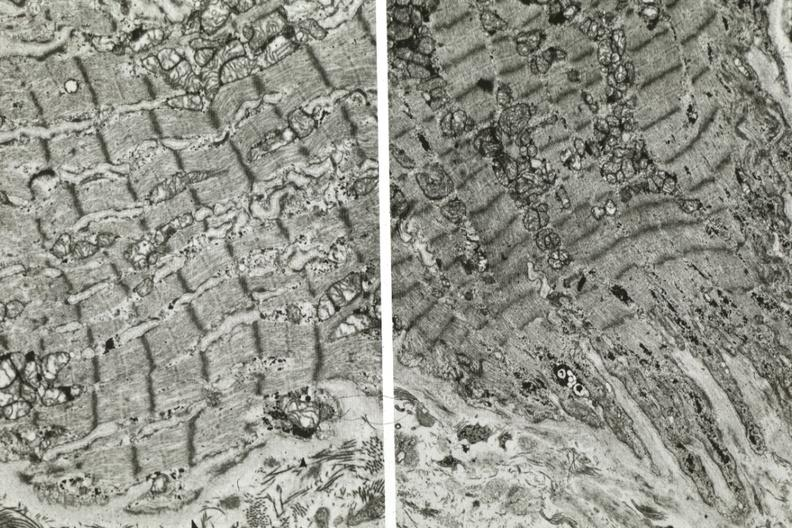what shows dilated sarcoplasmic reticulum?
Answer the question using a single word or phrase. Another fiber other frame 